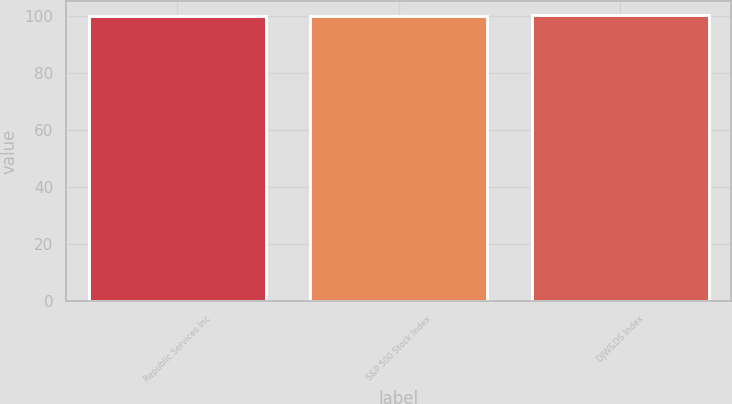Convert chart to OTSL. <chart><loc_0><loc_0><loc_500><loc_500><bar_chart><fcel>Republic Services Inc<fcel>S&P 500 Stock Index<fcel>DJW&DS Index<nl><fcel>100<fcel>100.1<fcel>100.2<nl></chart> 